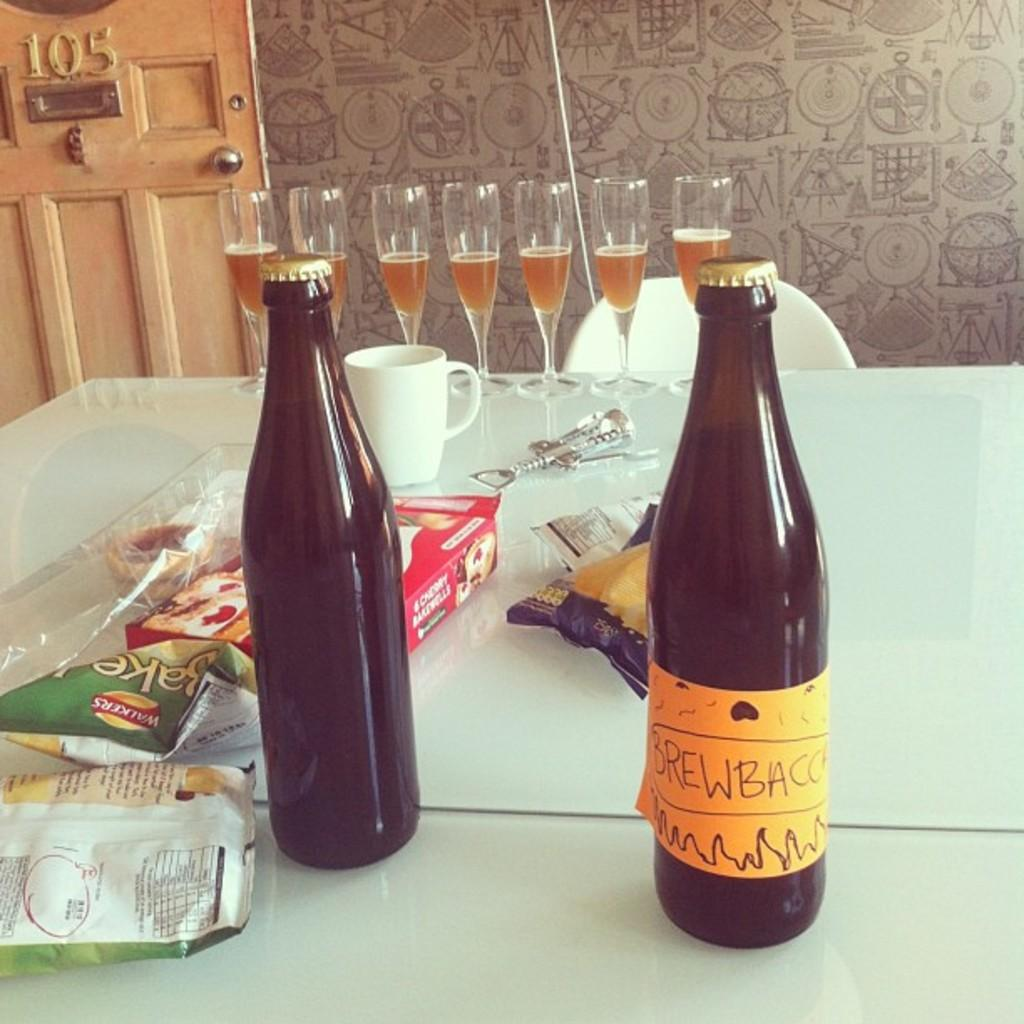Provide a one-sentence caption for the provided image. two bottles of Brew Bacc on a messy table. 